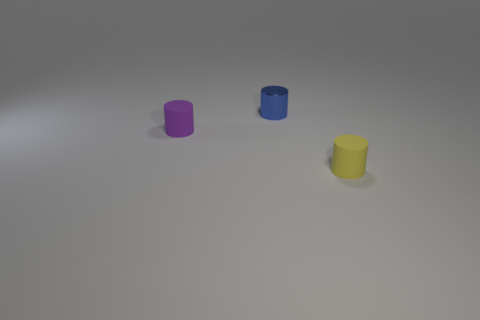What is the color of the matte object to the left of the small matte thing in front of the tiny rubber thing that is behind the yellow cylinder?
Give a very brief answer. Purple. There is a shiny cylinder; does it have the same color as the matte object that is right of the metal thing?
Offer a very short reply. No. Is the number of tiny rubber cylinders in front of the small metallic cylinder the same as the number of yellow matte cylinders?
Give a very brief answer. No. What number of blue metal objects have the same size as the yellow rubber thing?
Keep it short and to the point. 1. Are any yellow things visible?
Your response must be concise. Yes. Do the small object that is in front of the purple cylinder and the rubber thing that is left of the tiny blue thing have the same shape?
Your response must be concise. Yes. What number of large objects are green matte things or yellow objects?
Keep it short and to the point. 0. Do the yellow matte thing and the small purple matte thing have the same shape?
Your answer should be very brief. Yes. The metallic thing has what color?
Offer a very short reply. Blue. What number of things are tiny yellow rubber objects or small metallic things?
Your answer should be very brief. 2. 